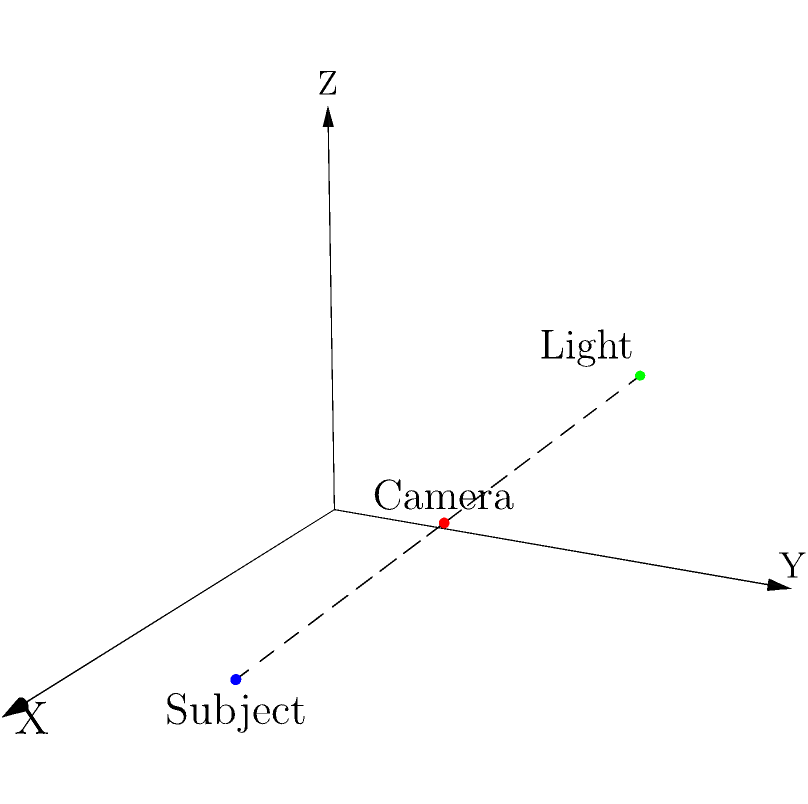In a 3D coordinate system, a camera is positioned at (2,2,1) and the subject is at (3,1,0). Based on your experience with indie film lighting, where should you place a key light to create optimal contrast and depth? Choose from the following options:

a) (1,3,2)
b) (3,3,1)
c) (2,1,2)
d) (1,1,1)

Explain your reasoning and how this placement would affect the visual quality of the shot. To determine the optimal lighting position, we need to consider several factors based on indie film lighting techniques:

1. Three-point lighting: In film, we often use a three-point lighting setup consisting of a key light, fill light, and backlight.

2. Key light position: The key light should be placed at an angle to the subject, typically 30-45 degrees from the camera-subject axis. This creates shadows and depth.

3. Height: The key light is usually placed slightly above the subject's eye level to create natural-looking shadows.

4. Distance: The light should be close enough to provide adequate illumination but far enough to create a soft, flattering light.

Analyzing the options:

a) (1,3,2): This position is ideal because:
   - It's at an angle to the camera-subject axis, creating depth.
   - It's higher than the subject (Z=2), providing a slight downward angle.
   - It's not too close or too far from the subject.

b) (3,3,1): This is too close to the subject and not high enough.
c) (2,1,2): This is almost behind the subject, which would create unflattering front lighting.
d) (1,1,1): This is too low and too close to the camera's position.

Option (a) (1,3,2) is the best choice as it satisfies all the criteria for optimal key light placement. This position would create a pleasing contrast on the subject's face, define their features with soft shadows, and add depth to the shot. It would enhance the three-dimensionality of the subject in the 2D medium of film, creating a more engaging and visually appealing image.
Answer: (1,3,2) 